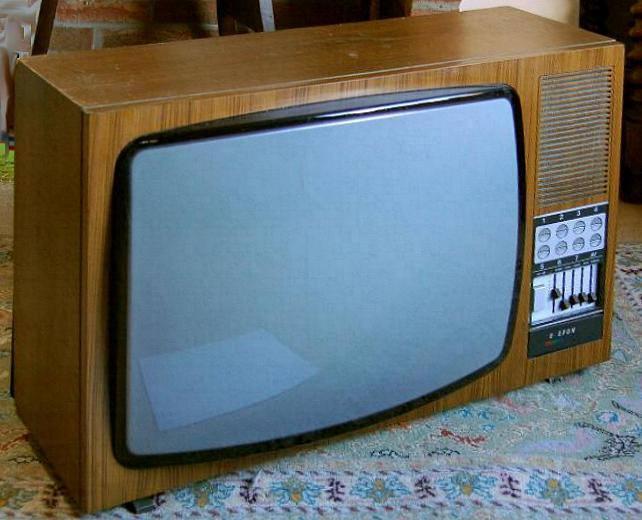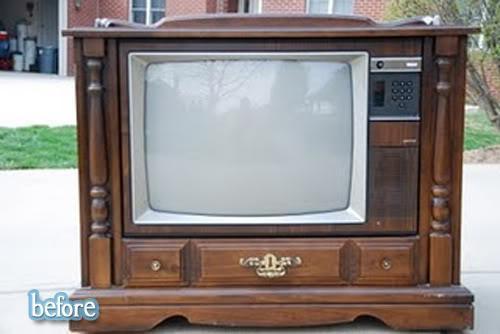The first image is the image on the left, the second image is the image on the right. For the images displayed, is the sentence "An image shows a TV screen displaying a pattern of squares with a circle in the center." factually correct? Answer yes or no. No. 